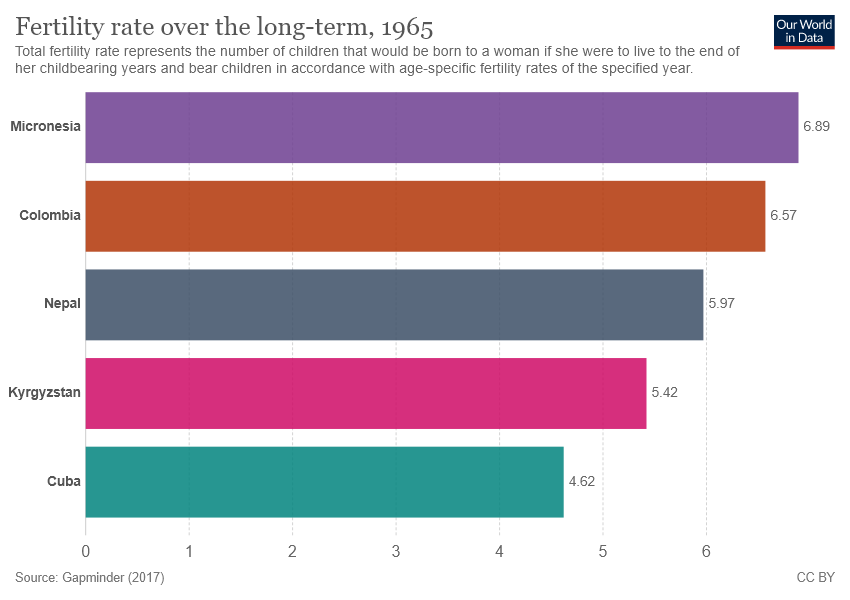Identify some key points in this picture. The value of the largest bar is 6.89. The sum of the smallest two bars is greater than the value of the largest bar. 